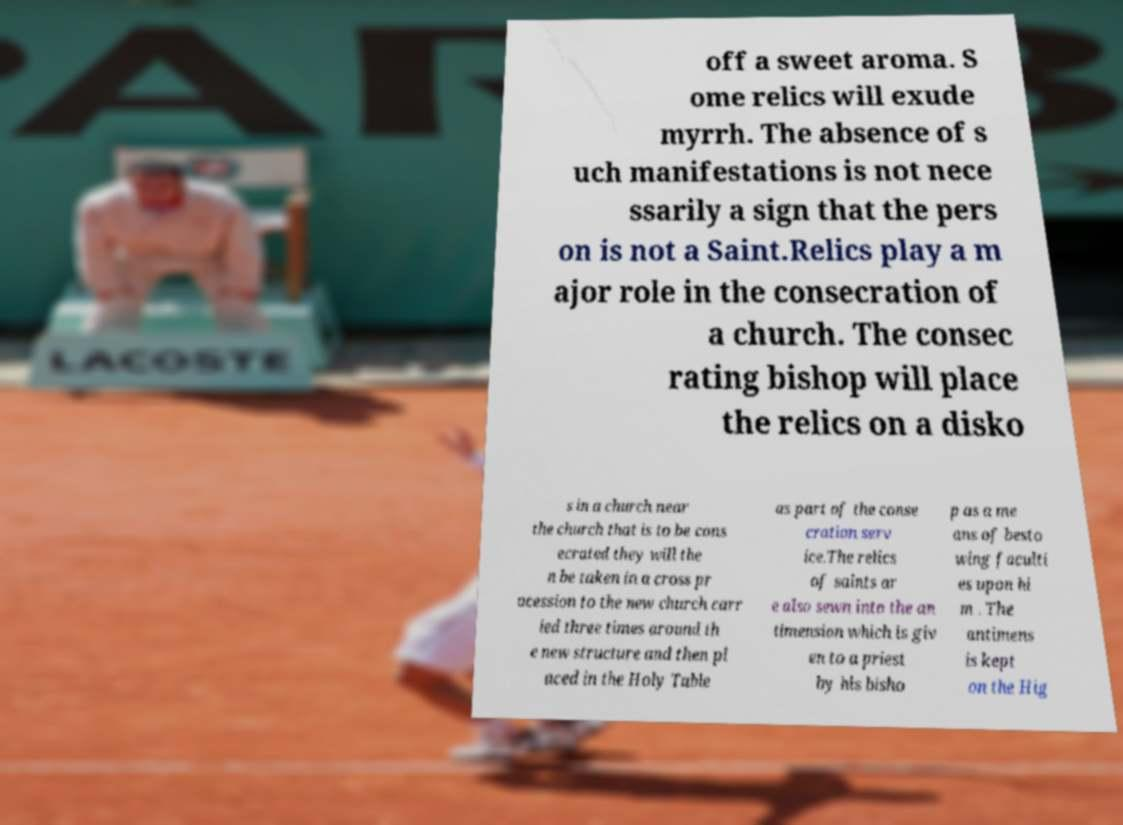Please read and relay the text visible in this image. What does it say? off a sweet aroma. S ome relics will exude myrrh. The absence of s uch manifestations is not nece ssarily a sign that the pers on is not a Saint.Relics play a m ajor role in the consecration of a church. The consec rating bishop will place the relics on a disko s in a church near the church that is to be cons ecrated they will the n be taken in a cross pr ocession to the new church carr ied three times around th e new structure and then pl aced in the Holy Table as part of the conse cration serv ice.The relics of saints ar e also sewn into the an timension which is giv en to a priest by his bisho p as a me ans of besto wing faculti es upon hi m . The antimens is kept on the Hig 